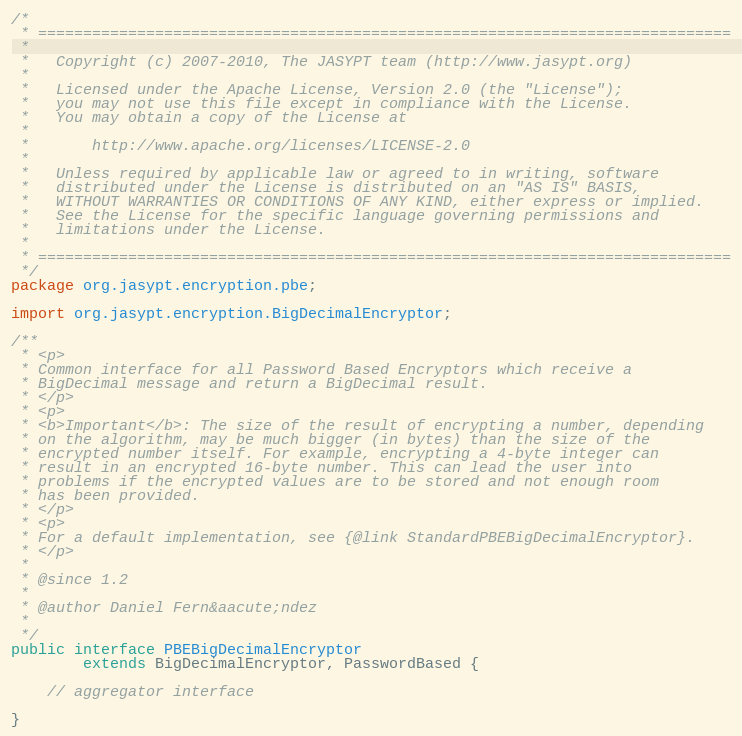Convert code to text. <code><loc_0><loc_0><loc_500><loc_500><_Java_>/*
 * =============================================================================
 * 
 *   Copyright (c) 2007-2010, The JASYPT team (http://www.jasypt.org)
 * 
 *   Licensed under the Apache License, Version 2.0 (the "License");
 *   you may not use this file except in compliance with the License.
 *   You may obtain a copy of the License at
 * 
 *       http://www.apache.org/licenses/LICENSE-2.0
 * 
 *   Unless required by applicable law or agreed to in writing, software
 *   distributed under the License is distributed on an "AS IS" BASIS,
 *   WITHOUT WARRANTIES OR CONDITIONS OF ANY KIND, either express or implied.
 *   See the License for the specific language governing permissions and
 *   limitations under the License.
 * 
 * =============================================================================
 */
package org.jasypt.encryption.pbe;

import org.jasypt.encryption.BigDecimalEncryptor;

/**
 * <p>
 * Common interface for all Password Based Encryptors which receive a 
 * BigDecimal message and return a BigDecimal result.
 * </p>
 * <p>
 * <b>Important</b>: The size of the result of encrypting a number, depending
 * on the algorithm, may be much bigger (in bytes) than the size of the 
 * encrypted number itself. For example, encrypting a 4-byte integer can
 * result in an encrypted 16-byte number. This can lead the user into 
 * problems if the encrypted values are to be stored and not enough room 
 * has been provided.
 * </p>
 * <p>
 * For a default implementation, see {@link StandardPBEBigDecimalEncryptor}.
 * </p>
 * 
 * @since 1.2
 * 
 * @author Daniel Fern&aacute;ndez
 * 
 */
public interface PBEBigDecimalEncryptor 
        extends BigDecimalEncryptor, PasswordBased {

    // aggregator interface
    
}
</code> 